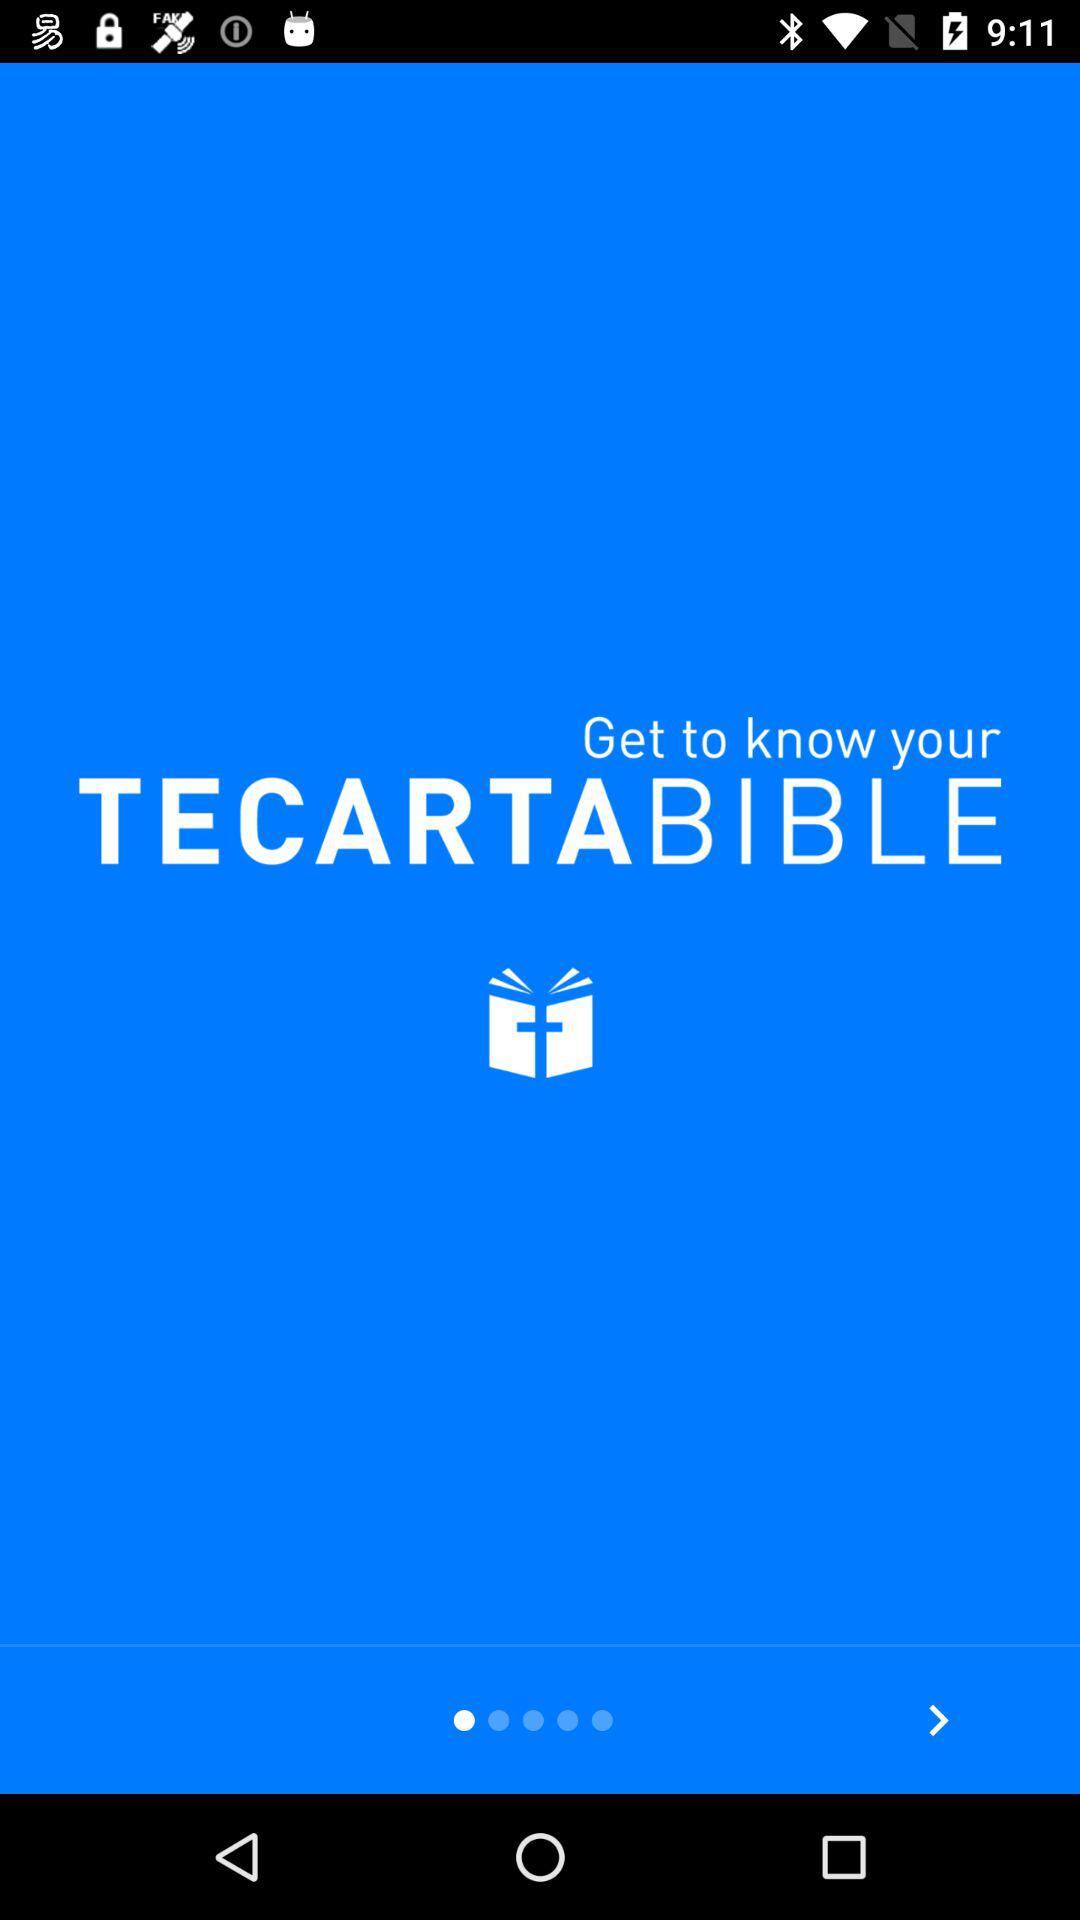What is the application name? The application name is "TECARTA BIBLE". 